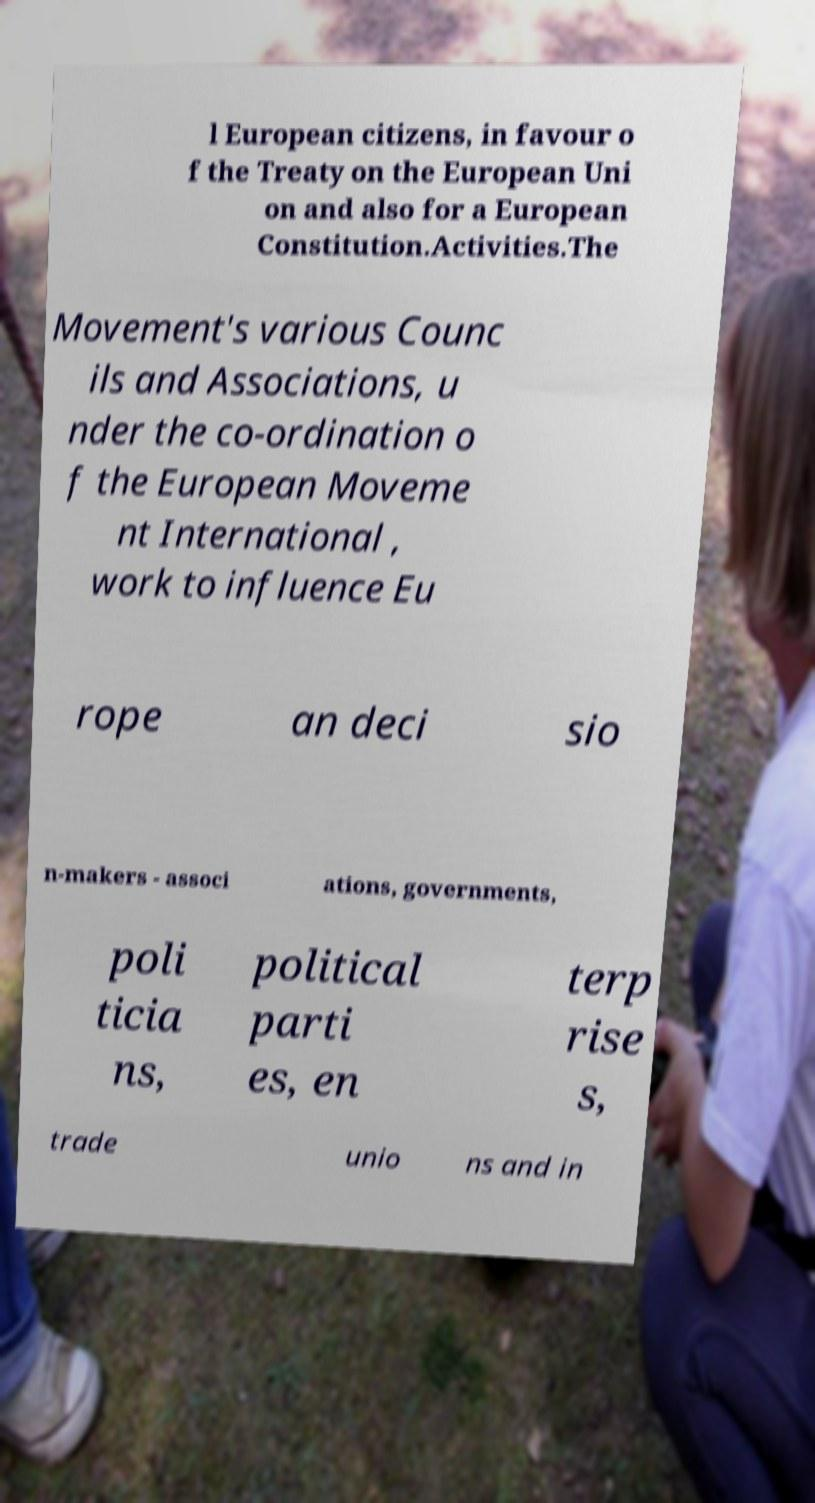Please read and relay the text visible in this image. What does it say? l European citizens, in favour o f the Treaty on the European Uni on and also for a European Constitution.Activities.The Movement's various Counc ils and Associations, u nder the co-ordination o f the European Moveme nt International , work to influence Eu rope an deci sio n-makers - associ ations, governments, poli ticia ns, political parti es, en terp rise s, trade unio ns and in 